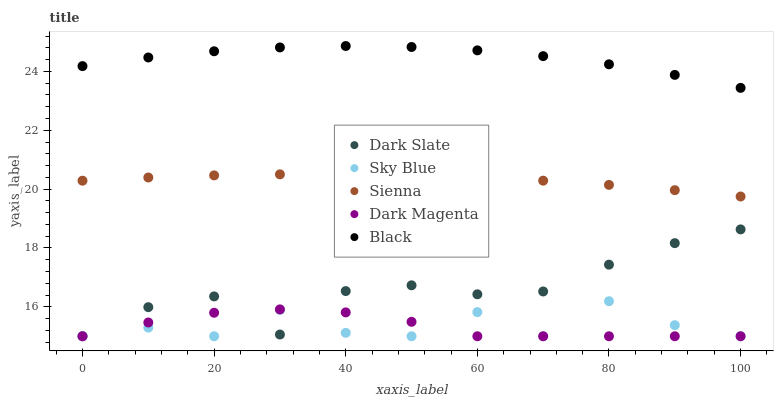Does Dark Magenta have the minimum area under the curve?
Answer yes or no. Yes. Does Black have the maximum area under the curve?
Answer yes or no. Yes. Does Dark Slate have the minimum area under the curve?
Answer yes or no. No. Does Dark Slate have the maximum area under the curve?
Answer yes or no. No. Is Sienna the smoothest?
Answer yes or no. Yes. Is Sky Blue the roughest?
Answer yes or no. Yes. Is Dark Slate the smoothest?
Answer yes or no. No. Is Dark Slate the roughest?
Answer yes or no. No. Does Dark Slate have the lowest value?
Answer yes or no. Yes. Does Black have the lowest value?
Answer yes or no. No. Does Black have the highest value?
Answer yes or no. Yes. Does Dark Slate have the highest value?
Answer yes or no. No. Is Sienna less than Black?
Answer yes or no. Yes. Is Black greater than Sienna?
Answer yes or no. Yes. Does Dark Slate intersect Sky Blue?
Answer yes or no. Yes. Is Dark Slate less than Sky Blue?
Answer yes or no. No. Is Dark Slate greater than Sky Blue?
Answer yes or no. No. Does Sienna intersect Black?
Answer yes or no. No. 